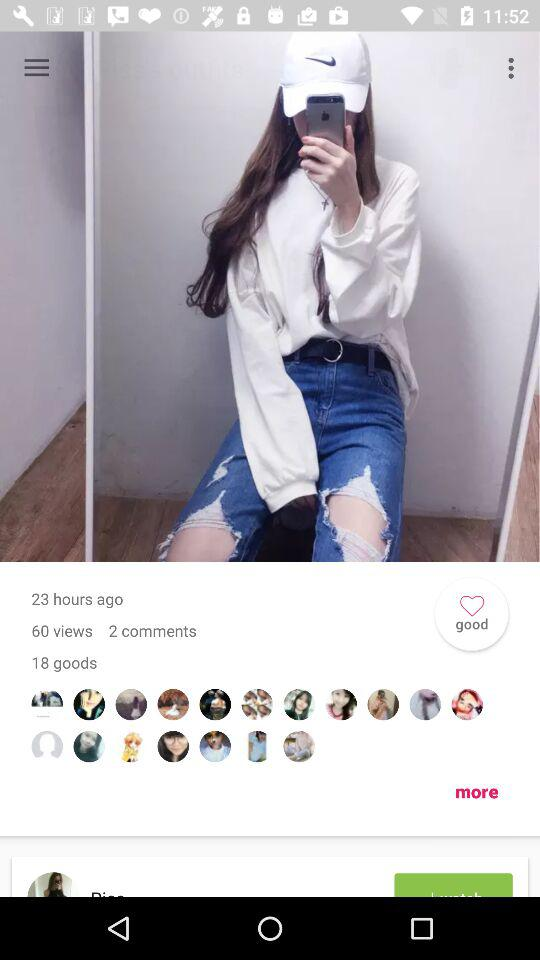How many hours ago did the photo get posted? The photo was posted 23 hours ago. 